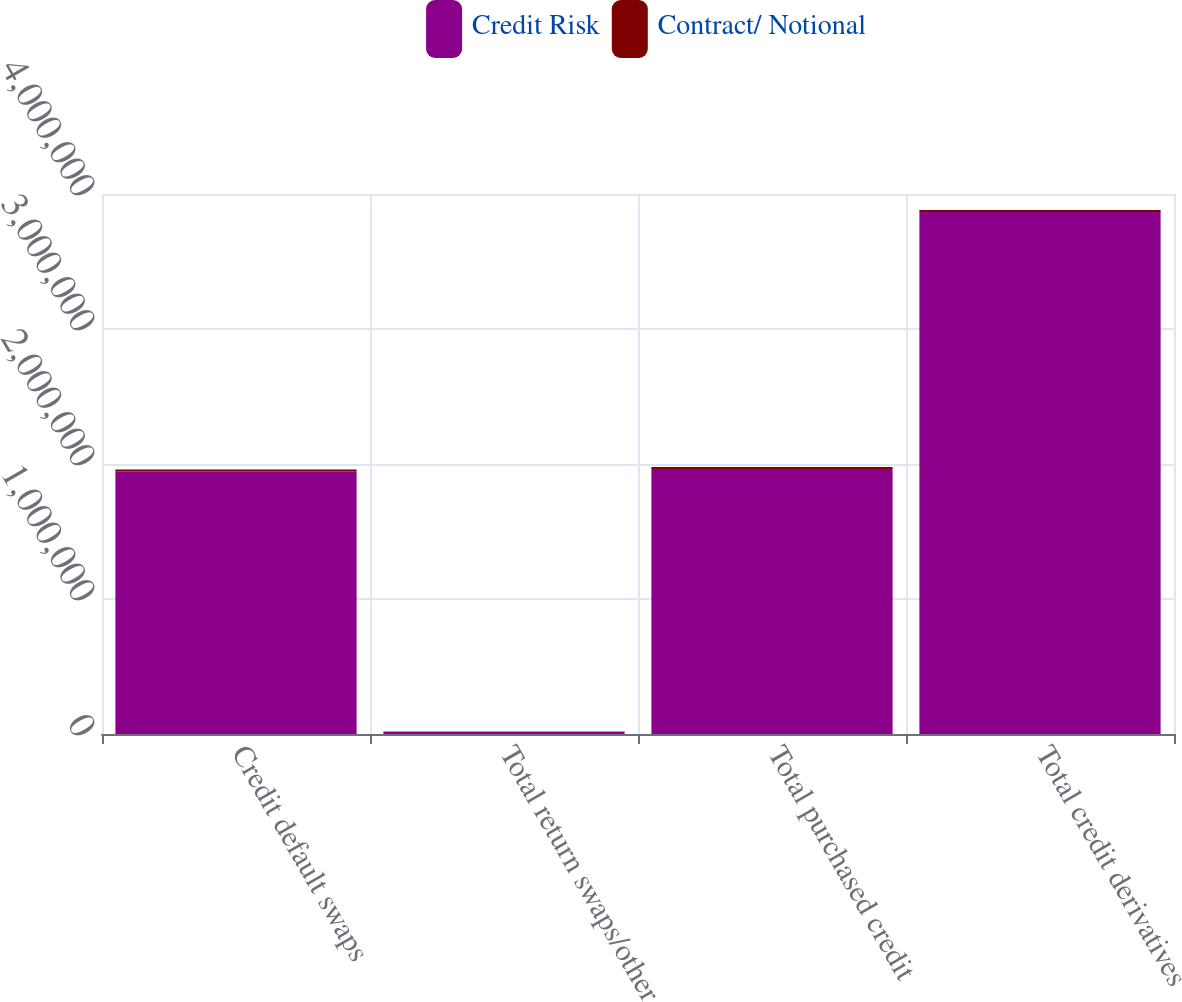Convert chart to OTSL. <chart><loc_0><loc_0><loc_500><loc_500><stacked_bar_chart><ecel><fcel>Credit default swaps<fcel>Total return swaps/other<fcel>Total purchased credit<fcel>Total credit derivatives<nl><fcel>Credit Risk<fcel>1.94476e+06<fcel>17519<fcel>1.96228e+06<fcel>3.86606e+06<nl><fcel>Contract/ Notional<fcel>14163<fcel>776<fcel>14939<fcel>14939<nl></chart> 